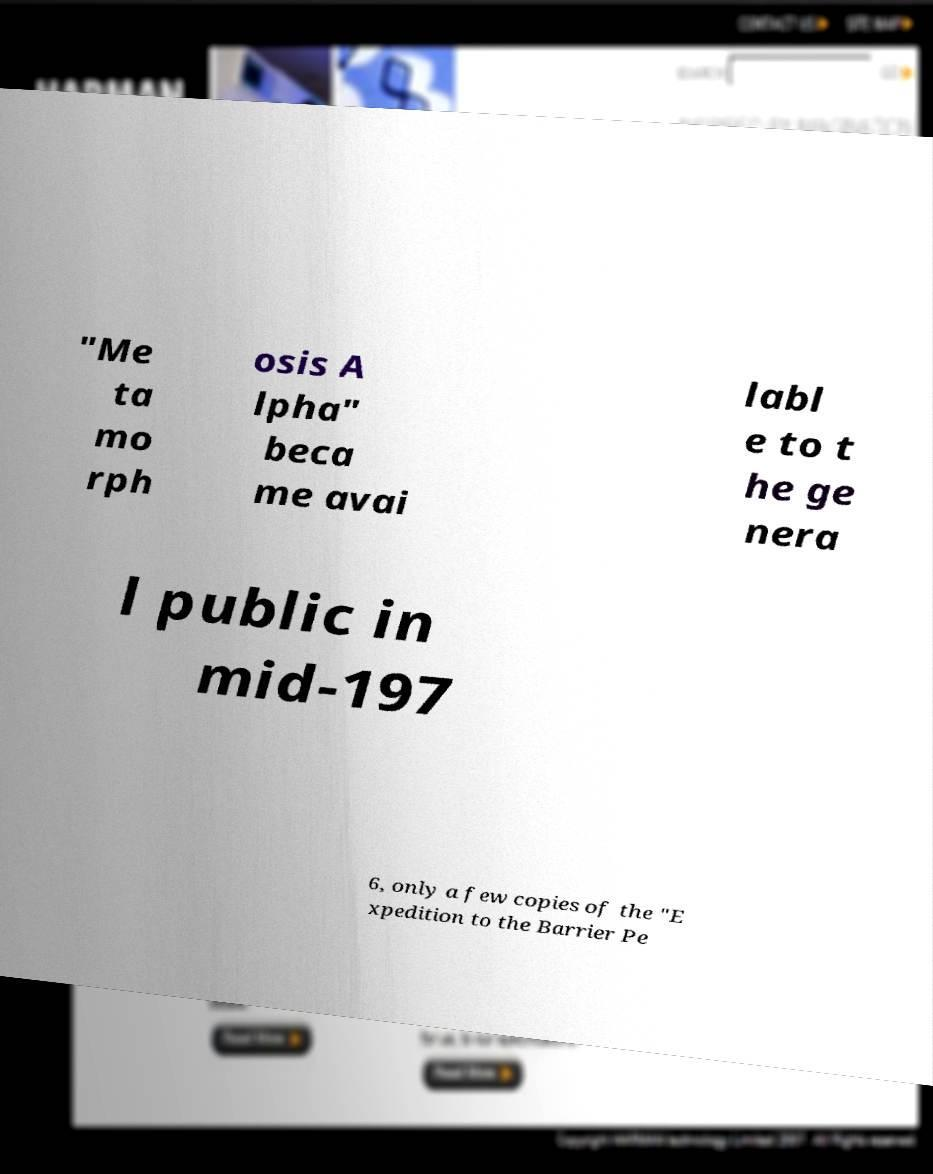Could you extract and type out the text from this image? "Me ta mo rph osis A lpha" beca me avai labl e to t he ge nera l public in mid-197 6, only a few copies of the "E xpedition to the Barrier Pe 